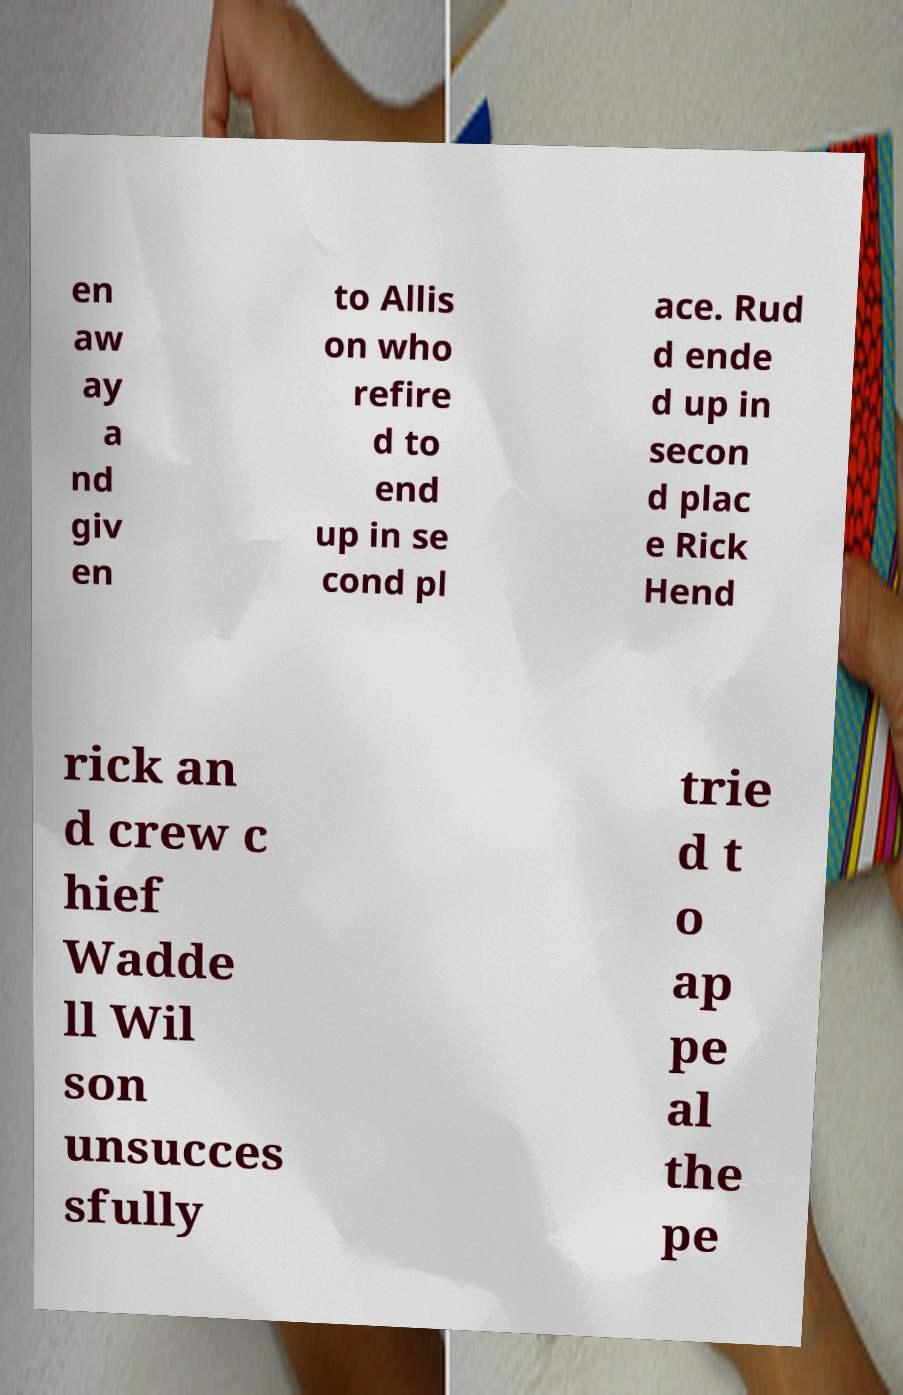Could you assist in decoding the text presented in this image and type it out clearly? en aw ay a nd giv en to Allis on who refire d to end up in se cond pl ace. Rud d ende d up in secon d plac e Rick Hend rick an d crew c hief Wadde ll Wil son unsucces sfully trie d t o ap pe al the pe 